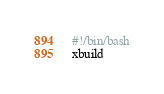<code> <loc_0><loc_0><loc_500><loc_500><_Bash_>#!/bin/bash
xbuild
</code> 